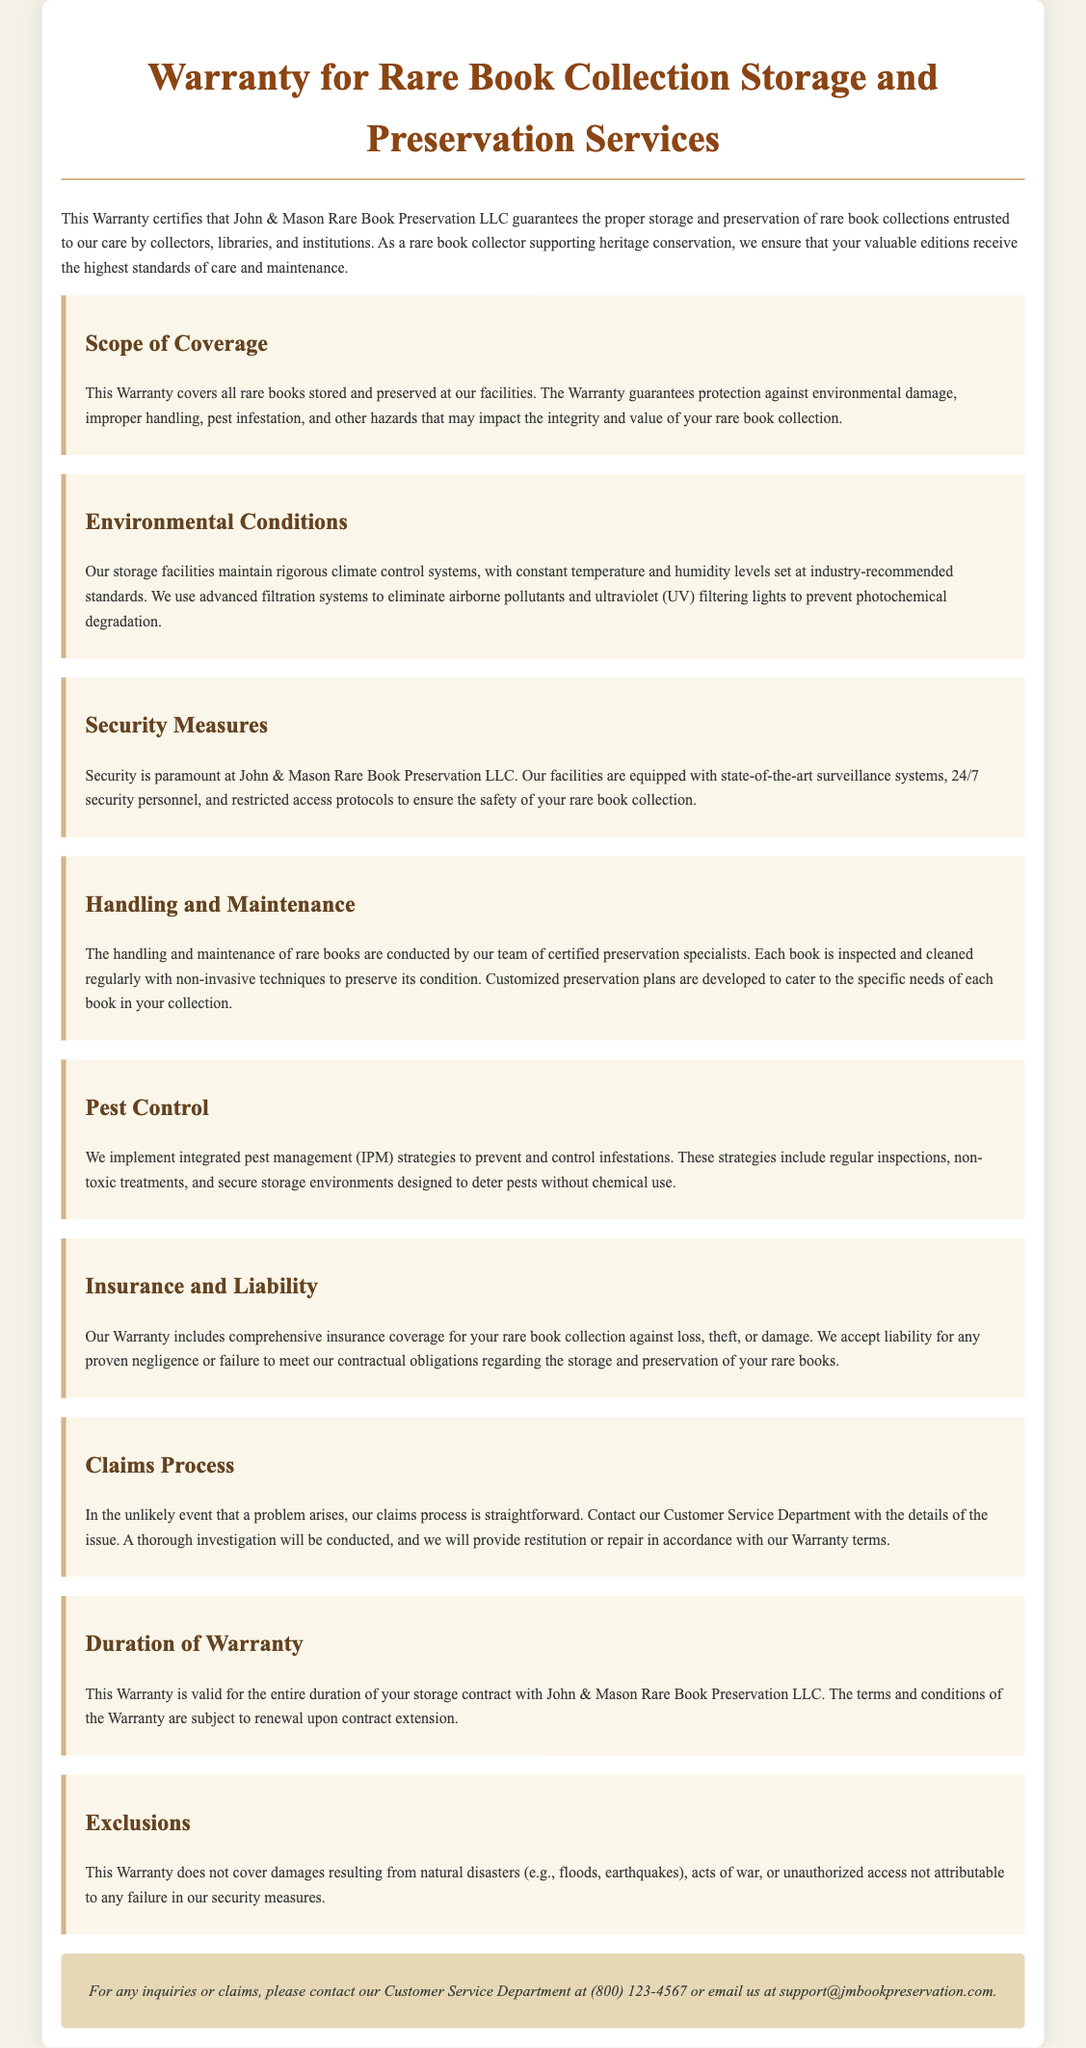What is the name of the company providing the warranty? The company providing the warranty is mentioned in the first paragraph of the document.
Answer: John & Mason Rare Book Preservation LLC What types of damage are covered under the warranty? The warranty covers various types of damage mentioned in the Scope of Coverage section.
Answer: Environmental damage, improper handling, pest infestation What is the primary security feature mentioned? The document outlines security measures, where the primary feature is highlighted.
Answer: Surveillance systems What is the contact phone number for inquiries? The contact information section provides a specific phone number for customer service.
Answer: (800) 123-4567 What does the warranty not cover? The Exclusions section clearly lists items that the warranty does not cover.
Answer: Natural disasters How long is the warranty valid? The Duration of Warranty section specifies how long the warranty is effective.
Answer: Duration of storage contract What type of pest management strategy is implemented? Pest Control section identifies the approach taken to manage pests.
Answer: Integrated pest management (IPM) Who conducts the handling and maintenance of rare books? The Handling and Maintenance section explicitly states the professionals involved.
Answer: Certified preservation specialists 